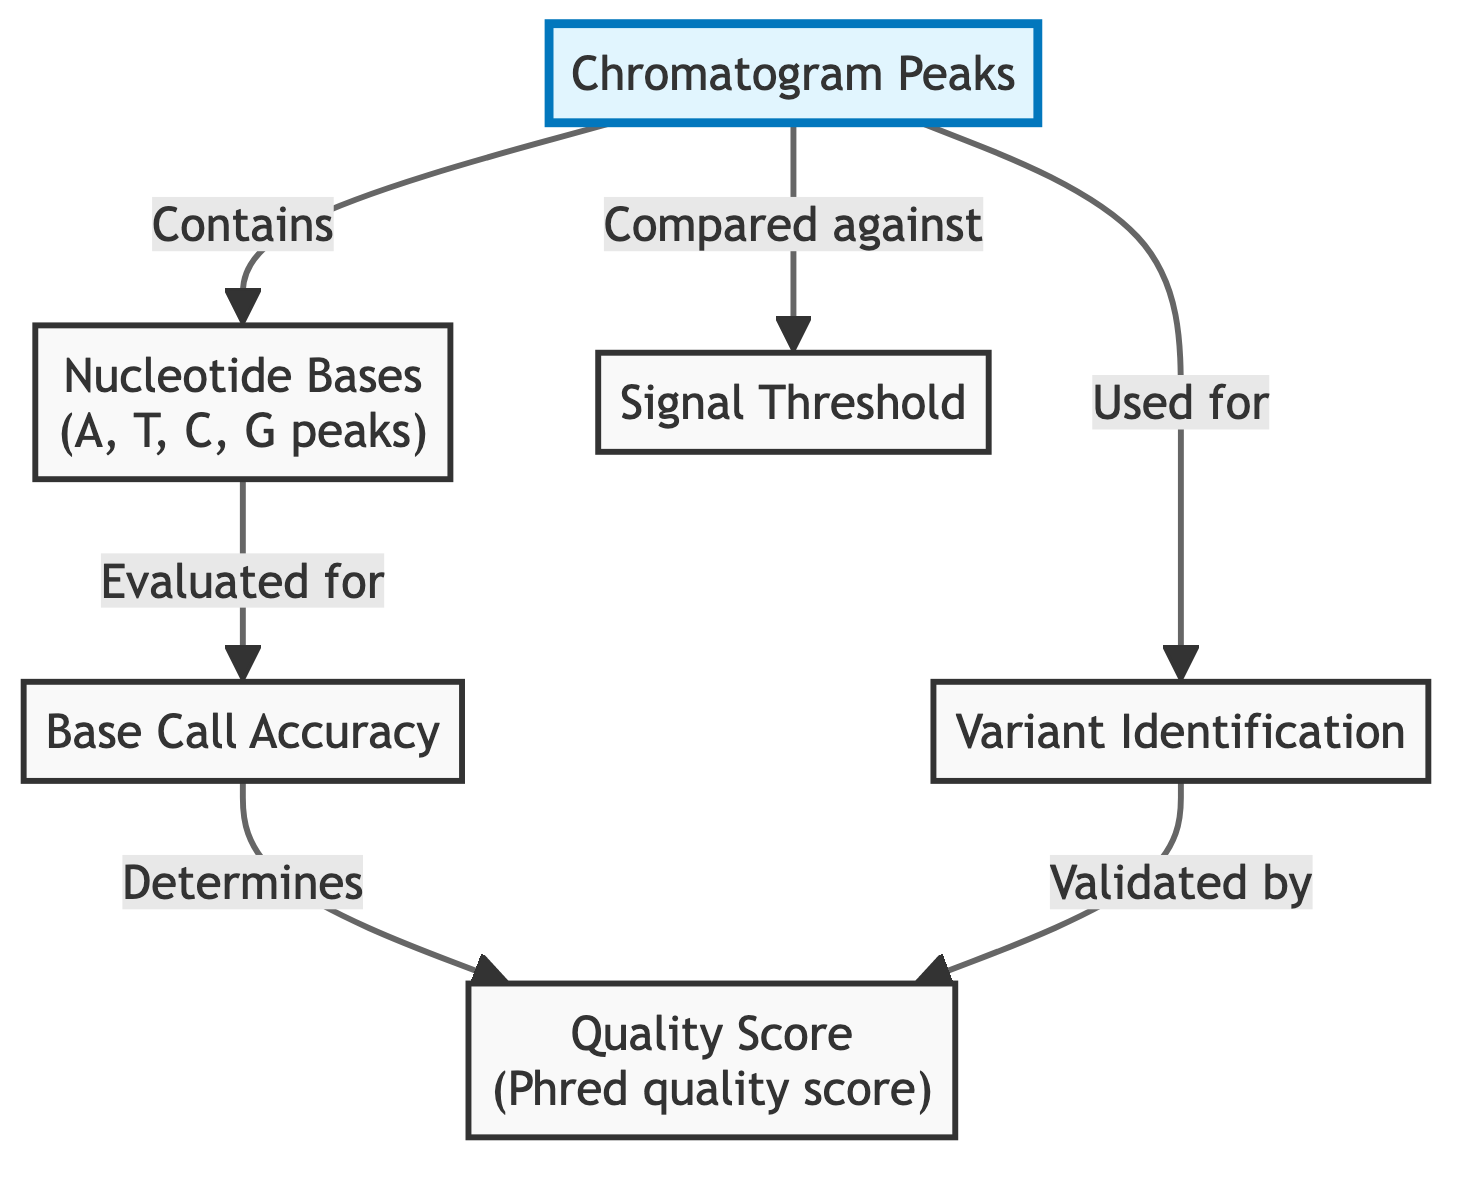What is shown at the top of the diagram? The top of the diagram shows "Chromatogram Peaks," which is highlighted to indicate its significance as the main subject of the diagram.
Answer: Chromatogram Peaks What relationship does "Base Call Accuracy" have with "Quality Score"? The arrow indicates that "Base Call Accuracy" determines the "Quality Score," implying that the accuracy of base calling directly influences the quality scoring of the data.
Answer: Determines How many nodes are represented in the diagram? The diagram has a total of six nodes, each labeled with distinct terminology relevant to chromatogram analysis in genetic testing.
Answer: Six What is the signal threshold compared against? The "Chromatogram Peaks" are compared against the "Signal Threshold," which suggests that the peaks must meet a particular threshold for valid interpretation.
Answer: Signal Threshold What process is "Variant Identification" used for? The diagram indicates that "Variant Identification" is used for analyzing chromatogram peaks, linking the identification of variants directly to the interpretation of peak data.
Answer: Analyzing chromatogram peaks What does the "Quality Score" represent? The "Quality Score" in the diagram, defined as the Phred quality score, represents a measure of the accuracy of the sequence calls, providing a quantifiable score for quality assessment.
Answer: Phred quality score What do "Nucleotide Bases" include? The "Nucleotide Bases" node includes the letters A, T, C, and G, representing the four nucleotides used in DNA sequencing.
Answer: A, T, C, G How is "Variant Identification" validated? According to the diagram, "Variant Identification" is validated by the "Quality Score," indicating that the identification process relies on quality assessment for confirmation.
Answer: Quality Score What does the flow from "Chromatogram Peaks" to "Signal Threshold" indicate? The flow indicates that the "Chromatogram Peaks" are compared against the "Signal Threshold," meaning the peaks need to be evaluated to determine if they meet the required signal levels for analysis.
Answer: Compared against 